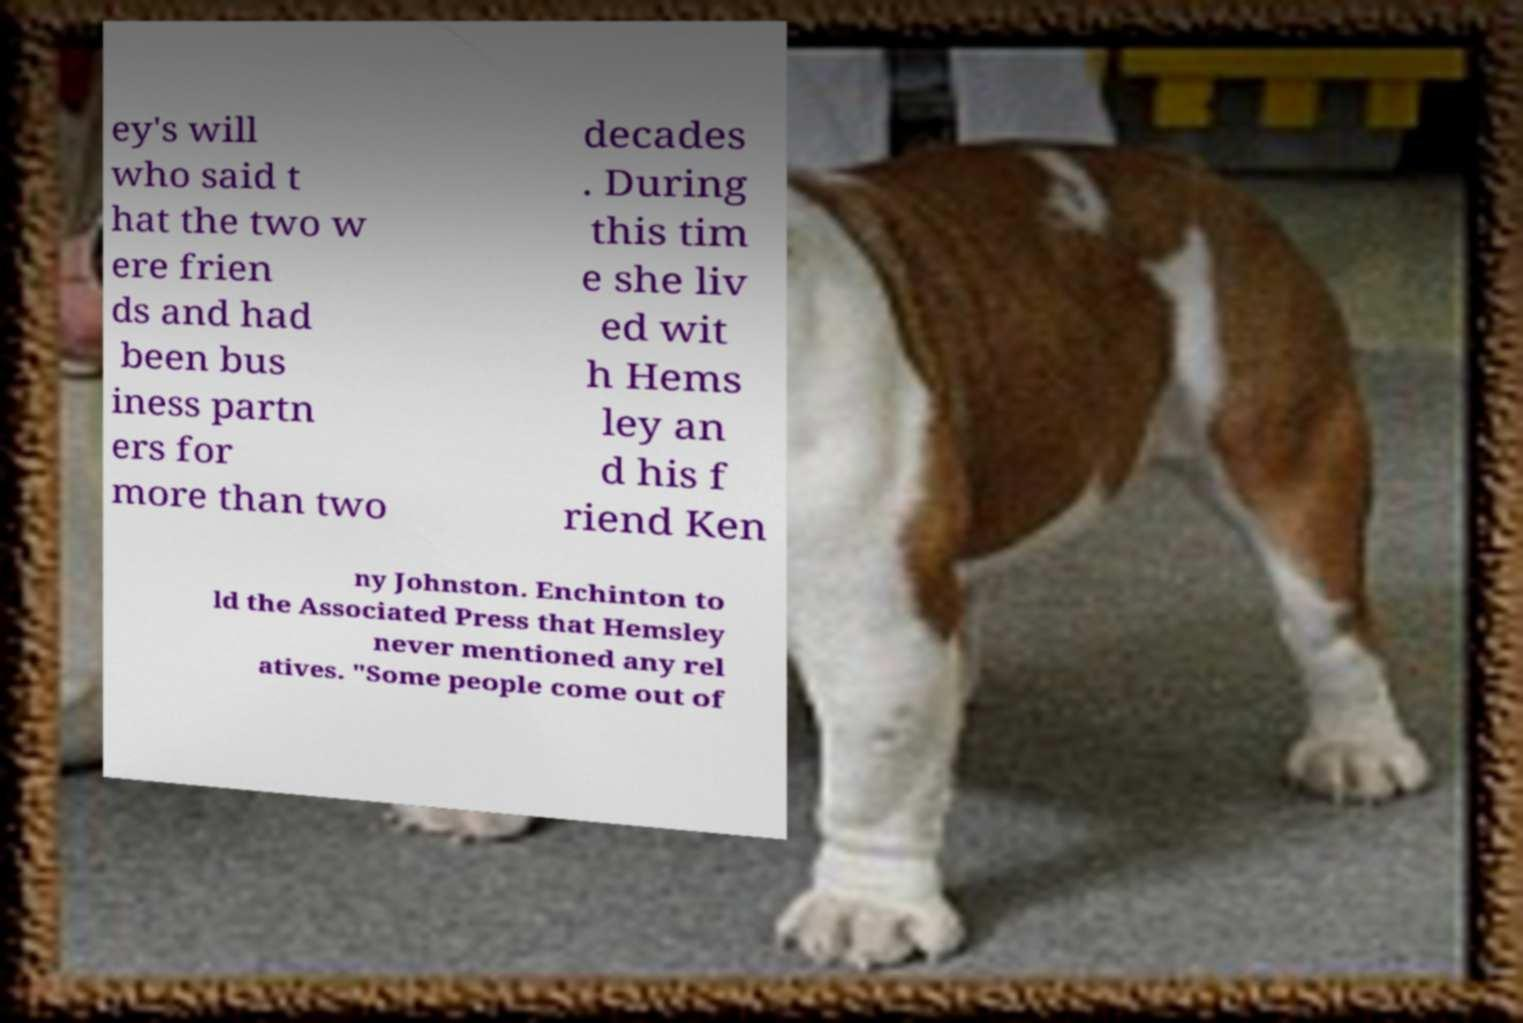What messages or text are displayed in this image? I need them in a readable, typed format. ey's will who said t hat the two w ere frien ds and had been bus iness partn ers for more than two decades . During this tim e she liv ed wit h Hems ley an d his f riend Ken ny Johnston. Enchinton to ld the Associated Press that Hemsley never mentioned any rel atives. "Some people come out of 